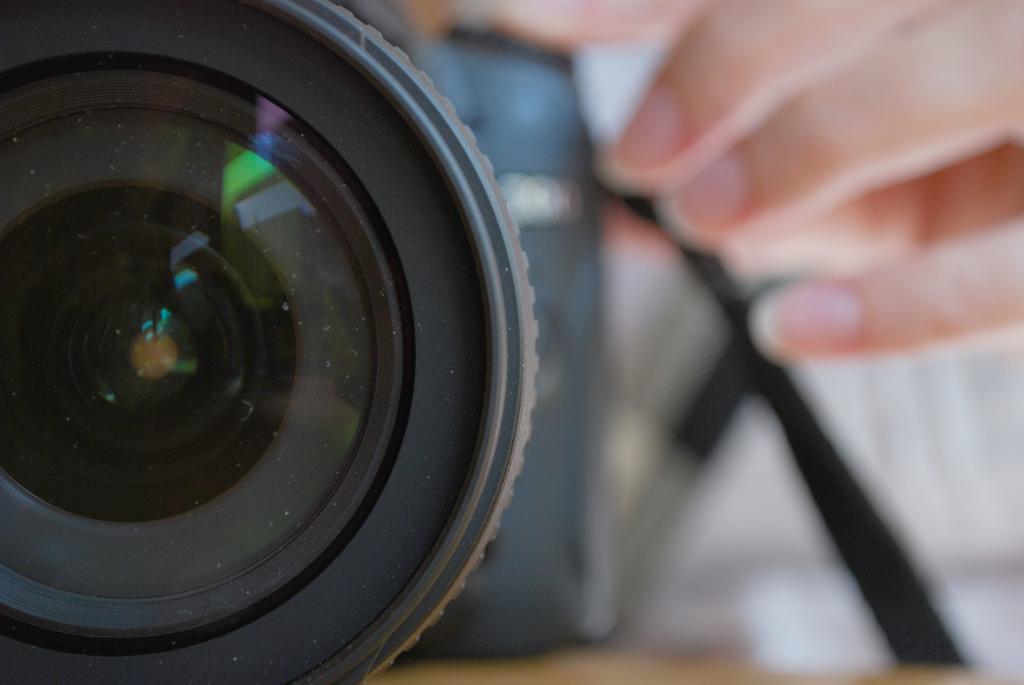Can you describe this image briefly? In this image, I can see a camera. In the background, there are fingers of a person. 